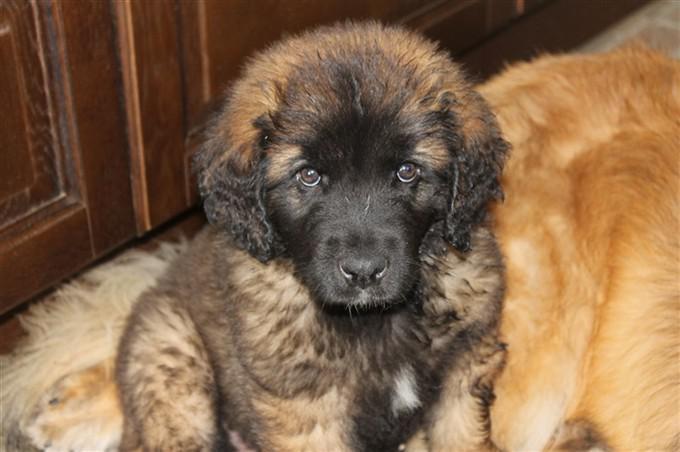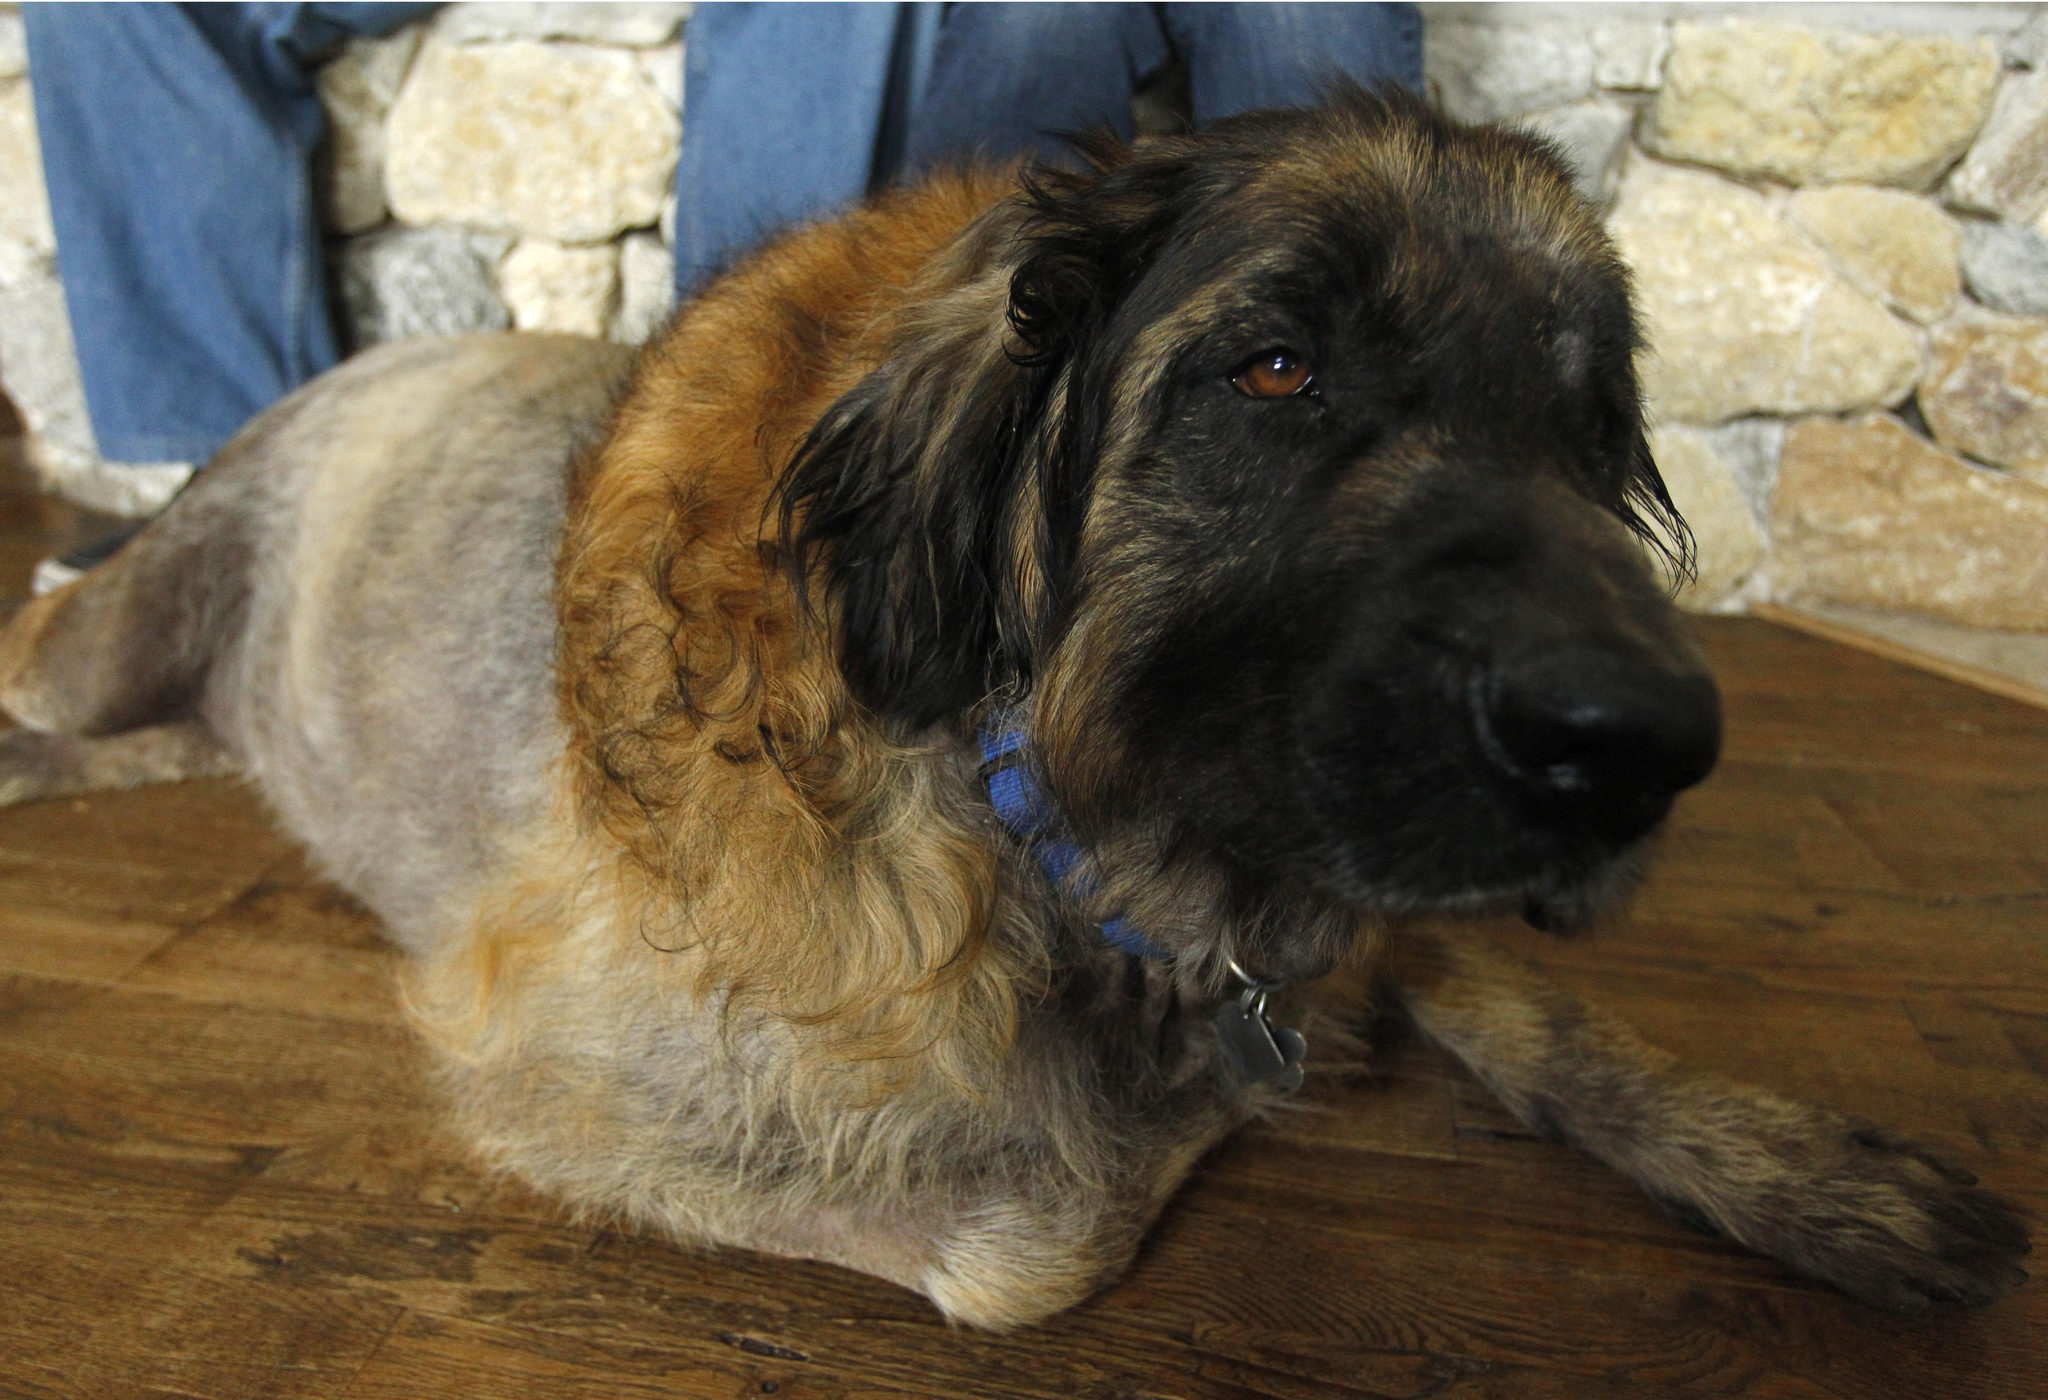The first image is the image on the left, the second image is the image on the right. Assess this claim about the two images: "A larger animal is partly visible to the right of a puppy in an indoor setting.". Correct or not? Answer yes or no. Yes. The first image is the image on the left, the second image is the image on the right. Assess this claim about the two images: "There are two dogs, and one visible tongue.". Correct or not? Answer yes or no. No. 